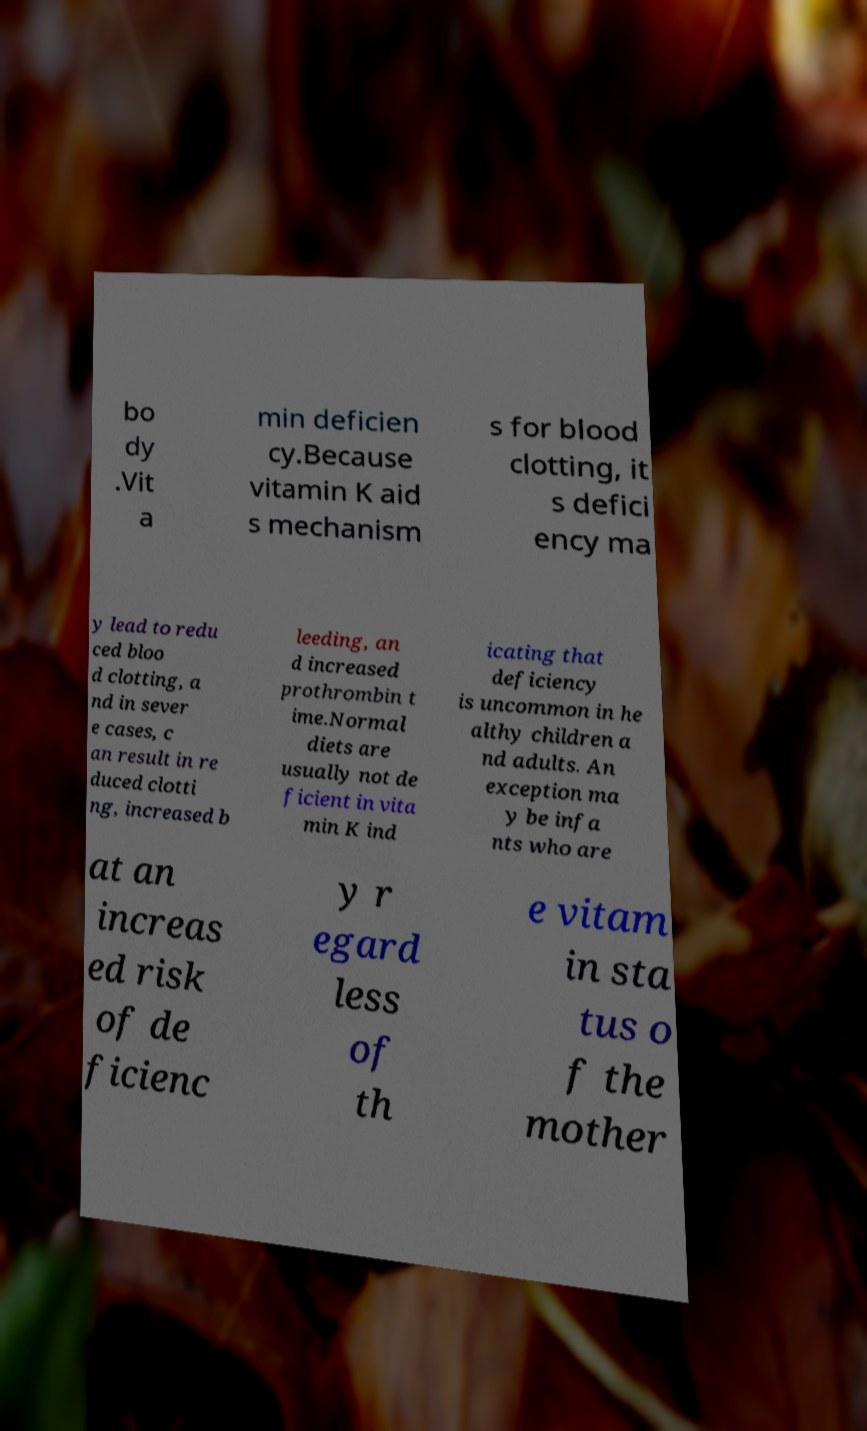Can you accurately transcribe the text from the provided image for me? bo dy .Vit a min deficien cy.Because vitamin K aid s mechanism s for blood clotting, it s defici ency ma y lead to redu ced bloo d clotting, a nd in sever e cases, c an result in re duced clotti ng, increased b leeding, an d increased prothrombin t ime.Normal diets are usually not de ficient in vita min K ind icating that deficiency is uncommon in he althy children a nd adults. An exception ma y be infa nts who are at an increas ed risk of de ficienc y r egard less of th e vitam in sta tus o f the mother 